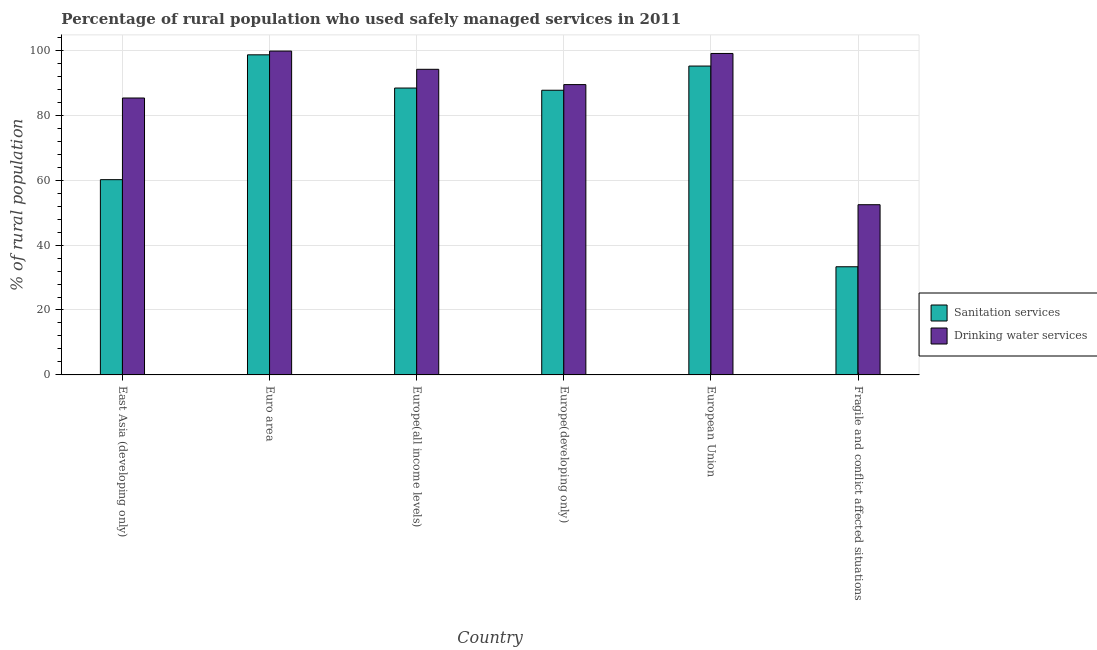How many groups of bars are there?
Offer a very short reply. 6. Are the number of bars per tick equal to the number of legend labels?
Offer a terse response. Yes. Are the number of bars on each tick of the X-axis equal?
Offer a very short reply. Yes. What is the label of the 6th group of bars from the left?
Ensure brevity in your answer.  Fragile and conflict affected situations. What is the percentage of rural population who used drinking water services in Fragile and conflict affected situations?
Your response must be concise. 52.43. Across all countries, what is the maximum percentage of rural population who used sanitation services?
Your response must be concise. 98.6. Across all countries, what is the minimum percentage of rural population who used sanitation services?
Your response must be concise. 33.31. In which country was the percentage of rural population who used sanitation services minimum?
Give a very brief answer. Fragile and conflict affected situations. What is the total percentage of rural population who used drinking water services in the graph?
Provide a succinct answer. 520.08. What is the difference between the percentage of rural population who used sanitation services in Euro area and that in Europe(developing only)?
Your response must be concise. 10.91. What is the difference between the percentage of rural population who used sanitation services in Euro area and the percentage of rural population who used drinking water services in European Union?
Offer a very short reply. -0.42. What is the average percentage of rural population who used sanitation services per country?
Provide a succinct answer. 77.21. What is the difference between the percentage of rural population who used sanitation services and percentage of rural population who used drinking water services in Fragile and conflict affected situations?
Offer a very short reply. -19.11. In how many countries, is the percentage of rural population who used drinking water services greater than 36 %?
Offer a terse response. 6. What is the ratio of the percentage of rural population who used drinking water services in European Union to that in Fragile and conflict affected situations?
Provide a short and direct response. 1.89. What is the difference between the highest and the second highest percentage of rural population who used sanitation services?
Your answer should be very brief. 3.46. What is the difference between the highest and the lowest percentage of rural population who used sanitation services?
Your response must be concise. 65.29. What does the 1st bar from the left in Europe(all income levels) represents?
Your answer should be compact. Sanitation services. What does the 2nd bar from the right in East Asia (developing only) represents?
Your response must be concise. Sanitation services. Are all the bars in the graph horizontal?
Your answer should be very brief. No. How many countries are there in the graph?
Provide a short and direct response. 6. What is the difference between two consecutive major ticks on the Y-axis?
Your response must be concise. 20. Does the graph contain grids?
Provide a short and direct response. Yes. Where does the legend appear in the graph?
Your response must be concise. Center right. How many legend labels are there?
Provide a succinct answer. 2. How are the legend labels stacked?
Give a very brief answer. Vertical. What is the title of the graph?
Make the answer very short. Percentage of rural population who used safely managed services in 2011. Does "Diarrhea" appear as one of the legend labels in the graph?
Give a very brief answer. No. What is the label or title of the X-axis?
Offer a very short reply. Country. What is the label or title of the Y-axis?
Keep it short and to the point. % of rural population. What is the % of rural population in Sanitation services in East Asia (developing only)?
Provide a succinct answer. 60.15. What is the % of rural population in Drinking water services in East Asia (developing only)?
Your answer should be compact. 85.3. What is the % of rural population in Sanitation services in Euro area?
Give a very brief answer. 98.6. What is the % of rural population of Drinking water services in Euro area?
Provide a succinct answer. 99.76. What is the % of rural population in Sanitation services in Europe(all income levels)?
Give a very brief answer. 88.37. What is the % of rural population in Drinking water services in Europe(all income levels)?
Keep it short and to the point. 94.14. What is the % of rural population in Sanitation services in Europe(developing only)?
Your response must be concise. 87.69. What is the % of rural population of Drinking water services in Europe(developing only)?
Provide a succinct answer. 89.43. What is the % of rural population in Sanitation services in European Union?
Ensure brevity in your answer.  95.14. What is the % of rural population in Drinking water services in European Union?
Give a very brief answer. 99.02. What is the % of rural population in Sanitation services in Fragile and conflict affected situations?
Your response must be concise. 33.31. What is the % of rural population in Drinking water services in Fragile and conflict affected situations?
Keep it short and to the point. 52.43. Across all countries, what is the maximum % of rural population in Sanitation services?
Keep it short and to the point. 98.6. Across all countries, what is the maximum % of rural population of Drinking water services?
Your answer should be very brief. 99.76. Across all countries, what is the minimum % of rural population of Sanitation services?
Your answer should be compact. 33.31. Across all countries, what is the minimum % of rural population of Drinking water services?
Make the answer very short. 52.43. What is the total % of rural population in Sanitation services in the graph?
Offer a very short reply. 463.27. What is the total % of rural population of Drinking water services in the graph?
Make the answer very short. 520.08. What is the difference between the % of rural population in Sanitation services in East Asia (developing only) and that in Euro area?
Keep it short and to the point. -38.45. What is the difference between the % of rural population of Drinking water services in East Asia (developing only) and that in Euro area?
Offer a terse response. -14.46. What is the difference between the % of rural population of Sanitation services in East Asia (developing only) and that in Europe(all income levels)?
Your response must be concise. -28.22. What is the difference between the % of rural population of Drinking water services in East Asia (developing only) and that in Europe(all income levels)?
Your answer should be very brief. -8.84. What is the difference between the % of rural population of Sanitation services in East Asia (developing only) and that in Europe(developing only)?
Your response must be concise. -27.55. What is the difference between the % of rural population of Drinking water services in East Asia (developing only) and that in Europe(developing only)?
Provide a short and direct response. -4.13. What is the difference between the % of rural population in Sanitation services in East Asia (developing only) and that in European Union?
Your response must be concise. -35. What is the difference between the % of rural population in Drinking water services in East Asia (developing only) and that in European Union?
Your answer should be very brief. -13.72. What is the difference between the % of rural population of Sanitation services in East Asia (developing only) and that in Fragile and conflict affected situations?
Ensure brevity in your answer.  26.83. What is the difference between the % of rural population of Drinking water services in East Asia (developing only) and that in Fragile and conflict affected situations?
Your answer should be very brief. 32.87. What is the difference between the % of rural population of Sanitation services in Euro area and that in Europe(all income levels)?
Provide a short and direct response. 10.23. What is the difference between the % of rural population in Drinking water services in Euro area and that in Europe(all income levels)?
Your answer should be compact. 5.62. What is the difference between the % of rural population of Sanitation services in Euro area and that in Europe(developing only)?
Make the answer very short. 10.91. What is the difference between the % of rural population in Drinking water services in Euro area and that in Europe(developing only)?
Ensure brevity in your answer.  10.33. What is the difference between the % of rural population in Sanitation services in Euro area and that in European Union?
Your answer should be compact. 3.46. What is the difference between the % of rural population of Drinking water services in Euro area and that in European Union?
Your response must be concise. 0.74. What is the difference between the % of rural population in Sanitation services in Euro area and that in Fragile and conflict affected situations?
Offer a very short reply. 65.29. What is the difference between the % of rural population of Drinking water services in Euro area and that in Fragile and conflict affected situations?
Ensure brevity in your answer.  47.33. What is the difference between the % of rural population in Sanitation services in Europe(all income levels) and that in Europe(developing only)?
Offer a terse response. 0.68. What is the difference between the % of rural population in Drinking water services in Europe(all income levels) and that in Europe(developing only)?
Your response must be concise. 4.71. What is the difference between the % of rural population in Sanitation services in Europe(all income levels) and that in European Union?
Keep it short and to the point. -6.77. What is the difference between the % of rural population in Drinking water services in Europe(all income levels) and that in European Union?
Provide a short and direct response. -4.88. What is the difference between the % of rural population in Sanitation services in Europe(all income levels) and that in Fragile and conflict affected situations?
Your answer should be very brief. 55.06. What is the difference between the % of rural population of Drinking water services in Europe(all income levels) and that in Fragile and conflict affected situations?
Keep it short and to the point. 41.71. What is the difference between the % of rural population of Sanitation services in Europe(developing only) and that in European Union?
Give a very brief answer. -7.45. What is the difference between the % of rural population in Drinking water services in Europe(developing only) and that in European Union?
Ensure brevity in your answer.  -9.6. What is the difference between the % of rural population of Sanitation services in Europe(developing only) and that in Fragile and conflict affected situations?
Keep it short and to the point. 54.38. What is the difference between the % of rural population of Drinking water services in Europe(developing only) and that in Fragile and conflict affected situations?
Your answer should be compact. 37. What is the difference between the % of rural population in Sanitation services in European Union and that in Fragile and conflict affected situations?
Provide a short and direct response. 61.83. What is the difference between the % of rural population in Drinking water services in European Union and that in Fragile and conflict affected situations?
Your answer should be very brief. 46.59. What is the difference between the % of rural population of Sanitation services in East Asia (developing only) and the % of rural population of Drinking water services in Euro area?
Your answer should be very brief. -39.61. What is the difference between the % of rural population of Sanitation services in East Asia (developing only) and the % of rural population of Drinking water services in Europe(all income levels)?
Keep it short and to the point. -33.99. What is the difference between the % of rural population in Sanitation services in East Asia (developing only) and the % of rural population in Drinking water services in Europe(developing only)?
Your answer should be compact. -29.28. What is the difference between the % of rural population in Sanitation services in East Asia (developing only) and the % of rural population in Drinking water services in European Union?
Keep it short and to the point. -38.88. What is the difference between the % of rural population in Sanitation services in East Asia (developing only) and the % of rural population in Drinking water services in Fragile and conflict affected situations?
Provide a short and direct response. 7.72. What is the difference between the % of rural population of Sanitation services in Euro area and the % of rural population of Drinking water services in Europe(all income levels)?
Provide a succinct answer. 4.46. What is the difference between the % of rural population in Sanitation services in Euro area and the % of rural population in Drinking water services in Europe(developing only)?
Give a very brief answer. 9.17. What is the difference between the % of rural population in Sanitation services in Euro area and the % of rural population in Drinking water services in European Union?
Keep it short and to the point. -0.42. What is the difference between the % of rural population in Sanitation services in Euro area and the % of rural population in Drinking water services in Fragile and conflict affected situations?
Offer a very short reply. 46.17. What is the difference between the % of rural population of Sanitation services in Europe(all income levels) and the % of rural population of Drinking water services in Europe(developing only)?
Offer a very short reply. -1.06. What is the difference between the % of rural population in Sanitation services in Europe(all income levels) and the % of rural population in Drinking water services in European Union?
Keep it short and to the point. -10.65. What is the difference between the % of rural population of Sanitation services in Europe(all income levels) and the % of rural population of Drinking water services in Fragile and conflict affected situations?
Ensure brevity in your answer.  35.94. What is the difference between the % of rural population in Sanitation services in Europe(developing only) and the % of rural population in Drinking water services in European Union?
Offer a terse response. -11.33. What is the difference between the % of rural population in Sanitation services in Europe(developing only) and the % of rural population in Drinking water services in Fragile and conflict affected situations?
Your response must be concise. 35.26. What is the difference between the % of rural population of Sanitation services in European Union and the % of rural population of Drinking water services in Fragile and conflict affected situations?
Give a very brief answer. 42.71. What is the average % of rural population of Sanitation services per country?
Make the answer very short. 77.21. What is the average % of rural population of Drinking water services per country?
Offer a terse response. 86.68. What is the difference between the % of rural population in Sanitation services and % of rural population in Drinking water services in East Asia (developing only)?
Keep it short and to the point. -25.15. What is the difference between the % of rural population in Sanitation services and % of rural population in Drinking water services in Euro area?
Offer a very short reply. -1.16. What is the difference between the % of rural population of Sanitation services and % of rural population of Drinking water services in Europe(all income levels)?
Ensure brevity in your answer.  -5.77. What is the difference between the % of rural population in Sanitation services and % of rural population in Drinking water services in Europe(developing only)?
Make the answer very short. -1.74. What is the difference between the % of rural population in Sanitation services and % of rural population in Drinking water services in European Union?
Make the answer very short. -3.88. What is the difference between the % of rural population of Sanitation services and % of rural population of Drinking water services in Fragile and conflict affected situations?
Give a very brief answer. -19.11. What is the ratio of the % of rural population in Sanitation services in East Asia (developing only) to that in Euro area?
Provide a short and direct response. 0.61. What is the ratio of the % of rural population in Drinking water services in East Asia (developing only) to that in Euro area?
Offer a very short reply. 0.85. What is the ratio of the % of rural population in Sanitation services in East Asia (developing only) to that in Europe(all income levels)?
Your response must be concise. 0.68. What is the ratio of the % of rural population in Drinking water services in East Asia (developing only) to that in Europe(all income levels)?
Your answer should be very brief. 0.91. What is the ratio of the % of rural population in Sanitation services in East Asia (developing only) to that in Europe(developing only)?
Offer a very short reply. 0.69. What is the ratio of the % of rural population in Drinking water services in East Asia (developing only) to that in Europe(developing only)?
Provide a short and direct response. 0.95. What is the ratio of the % of rural population of Sanitation services in East Asia (developing only) to that in European Union?
Keep it short and to the point. 0.63. What is the ratio of the % of rural population in Drinking water services in East Asia (developing only) to that in European Union?
Your response must be concise. 0.86. What is the ratio of the % of rural population in Sanitation services in East Asia (developing only) to that in Fragile and conflict affected situations?
Your answer should be compact. 1.81. What is the ratio of the % of rural population in Drinking water services in East Asia (developing only) to that in Fragile and conflict affected situations?
Your answer should be compact. 1.63. What is the ratio of the % of rural population in Sanitation services in Euro area to that in Europe(all income levels)?
Give a very brief answer. 1.12. What is the ratio of the % of rural population of Drinking water services in Euro area to that in Europe(all income levels)?
Your answer should be very brief. 1.06. What is the ratio of the % of rural population in Sanitation services in Euro area to that in Europe(developing only)?
Your answer should be very brief. 1.12. What is the ratio of the % of rural population of Drinking water services in Euro area to that in Europe(developing only)?
Ensure brevity in your answer.  1.12. What is the ratio of the % of rural population of Sanitation services in Euro area to that in European Union?
Provide a succinct answer. 1.04. What is the ratio of the % of rural population of Drinking water services in Euro area to that in European Union?
Provide a short and direct response. 1.01. What is the ratio of the % of rural population in Sanitation services in Euro area to that in Fragile and conflict affected situations?
Keep it short and to the point. 2.96. What is the ratio of the % of rural population in Drinking water services in Euro area to that in Fragile and conflict affected situations?
Offer a terse response. 1.9. What is the ratio of the % of rural population of Sanitation services in Europe(all income levels) to that in Europe(developing only)?
Keep it short and to the point. 1.01. What is the ratio of the % of rural population in Drinking water services in Europe(all income levels) to that in Europe(developing only)?
Offer a terse response. 1.05. What is the ratio of the % of rural population in Sanitation services in Europe(all income levels) to that in European Union?
Ensure brevity in your answer.  0.93. What is the ratio of the % of rural population of Drinking water services in Europe(all income levels) to that in European Union?
Provide a short and direct response. 0.95. What is the ratio of the % of rural population in Sanitation services in Europe(all income levels) to that in Fragile and conflict affected situations?
Provide a succinct answer. 2.65. What is the ratio of the % of rural population in Drinking water services in Europe(all income levels) to that in Fragile and conflict affected situations?
Keep it short and to the point. 1.8. What is the ratio of the % of rural population of Sanitation services in Europe(developing only) to that in European Union?
Your answer should be very brief. 0.92. What is the ratio of the % of rural population of Drinking water services in Europe(developing only) to that in European Union?
Your answer should be very brief. 0.9. What is the ratio of the % of rural population of Sanitation services in Europe(developing only) to that in Fragile and conflict affected situations?
Your answer should be compact. 2.63. What is the ratio of the % of rural population of Drinking water services in Europe(developing only) to that in Fragile and conflict affected situations?
Provide a short and direct response. 1.71. What is the ratio of the % of rural population in Sanitation services in European Union to that in Fragile and conflict affected situations?
Keep it short and to the point. 2.86. What is the ratio of the % of rural population in Drinking water services in European Union to that in Fragile and conflict affected situations?
Keep it short and to the point. 1.89. What is the difference between the highest and the second highest % of rural population of Sanitation services?
Offer a terse response. 3.46. What is the difference between the highest and the second highest % of rural population in Drinking water services?
Give a very brief answer. 0.74. What is the difference between the highest and the lowest % of rural population of Sanitation services?
Offer a terse response. 65.29. What is the difference between the highest and the lowest % of rural population in Drinking water services?
Give a very brief answer. 47.33. 